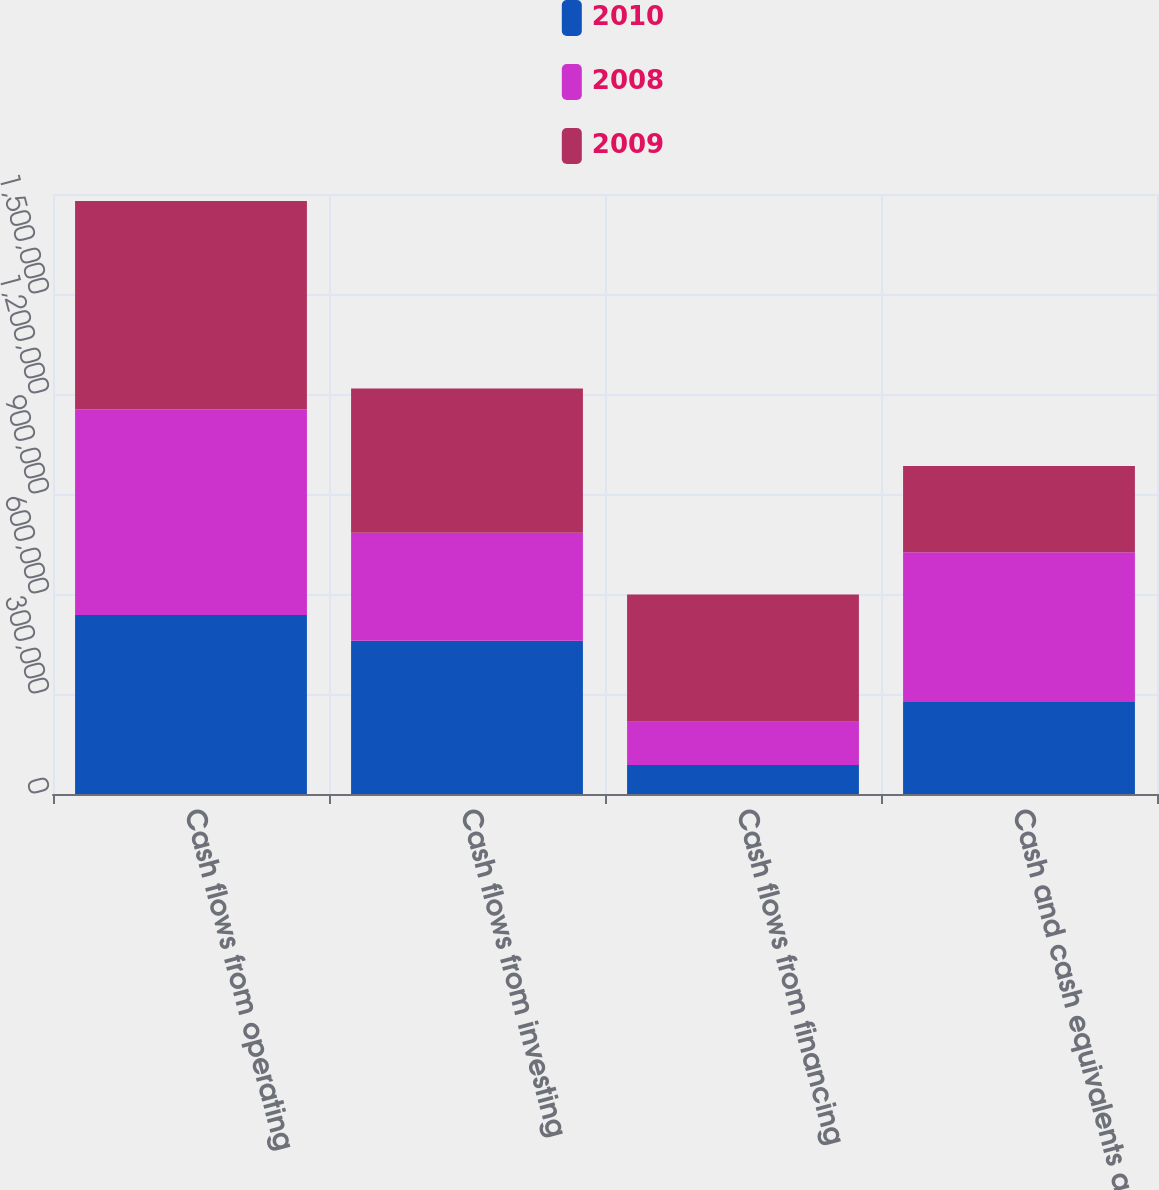<chart> <loc_0><loc_0><loc_500><loc_500><stacked_bar_chart><ecel><fcel>Cash flows from operating<fcel>Cash flows from investing<fcel>Cash flows from financing<fcel>Cash and cash equivalents at<nl><fcel>2010<fcel>537029<fcel>459594<fcel>87368<fcel>278370<nl><fcel>2008<fcel>616911<fcel>324066<fcel>129692<fcel>446656<nl><fcel>2009<fcel>625140<fcel>432670<fcel>381234<fcel>258693<nl></chart> 